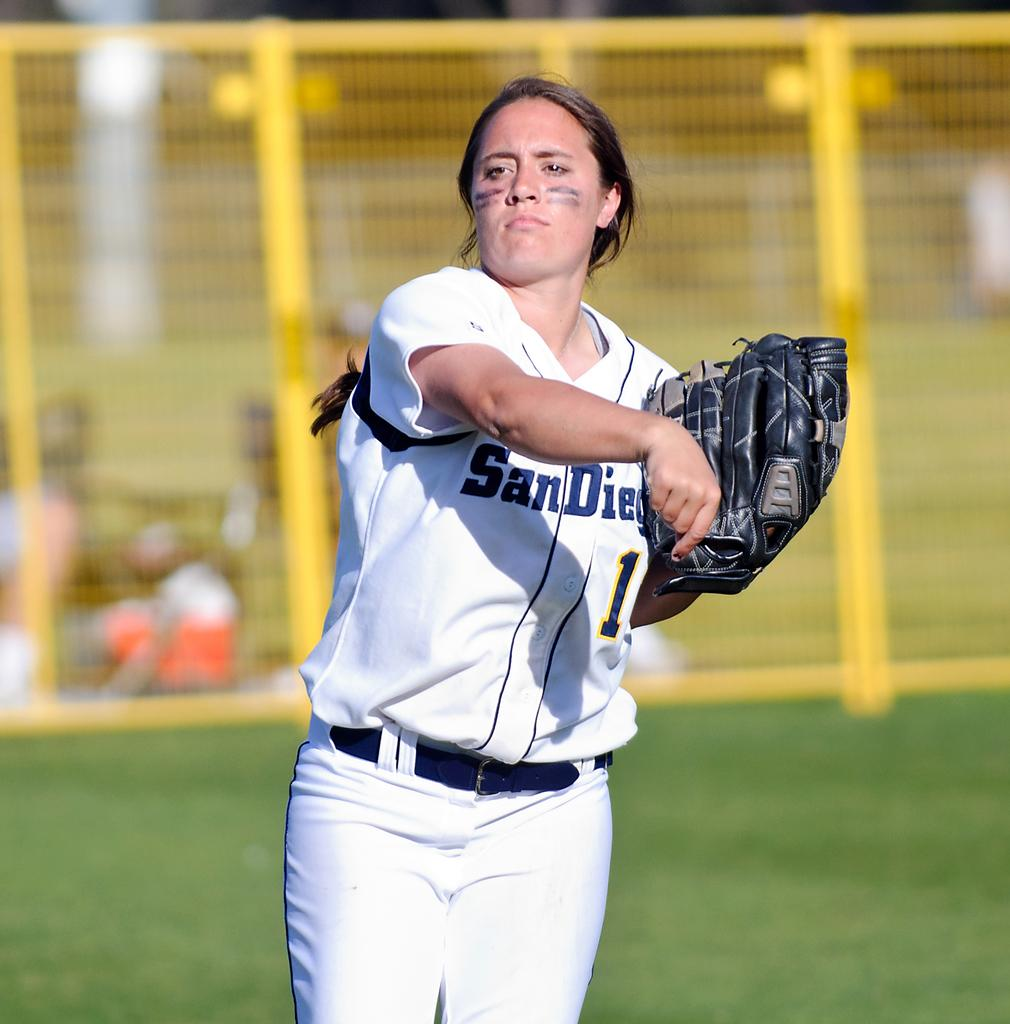Provide a one-sentence caption for the provided image. A girl wearing a San Diego softball uniform is holding a black glove. 